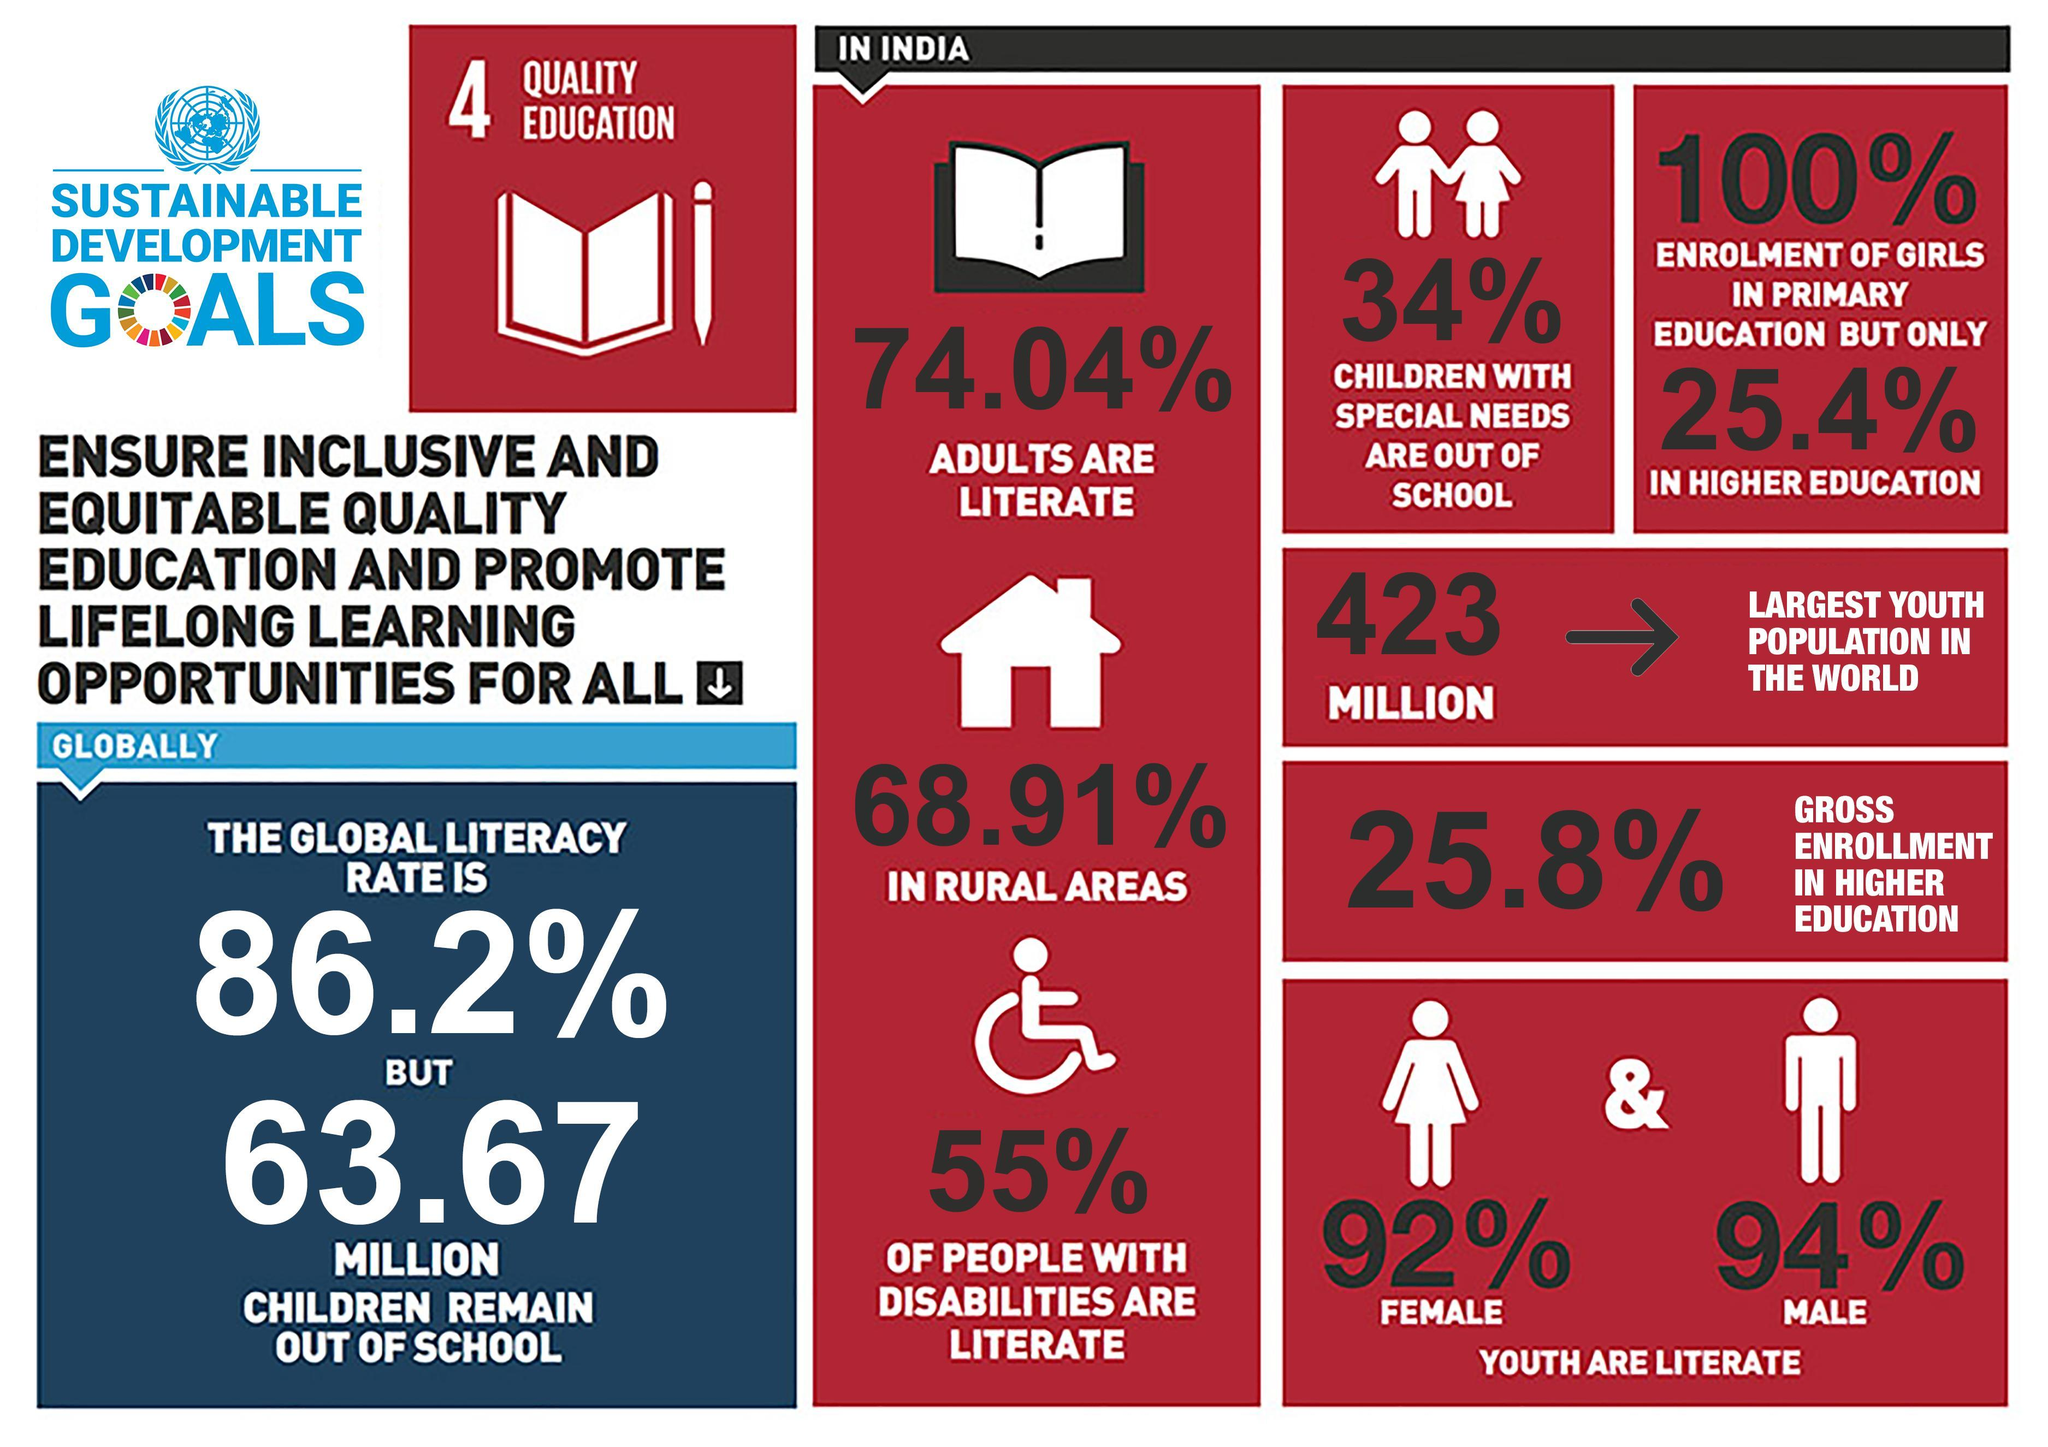What is the percentage of enrollment of girls in higher education in India?
Answer the question with a short phrase. 25.4% What percentage of people with disabilities are illiterate in India? 45% What percentage of literate youth in India are males? 94% What is the percentage of gross enrollment in higher education in India? 25.8% What percentage of literate youth in India are females? 92% What percentage of children with special needs are out of school in India? 34% What is the global population of children who remain out of school? 63.67 MILLION What is the percentage of enrollment of girls in primary education in India? 100% What percentage of people in rural areas of India are illiterate? 31.09% What percentage of adults in India are illiterate? 25.96% 